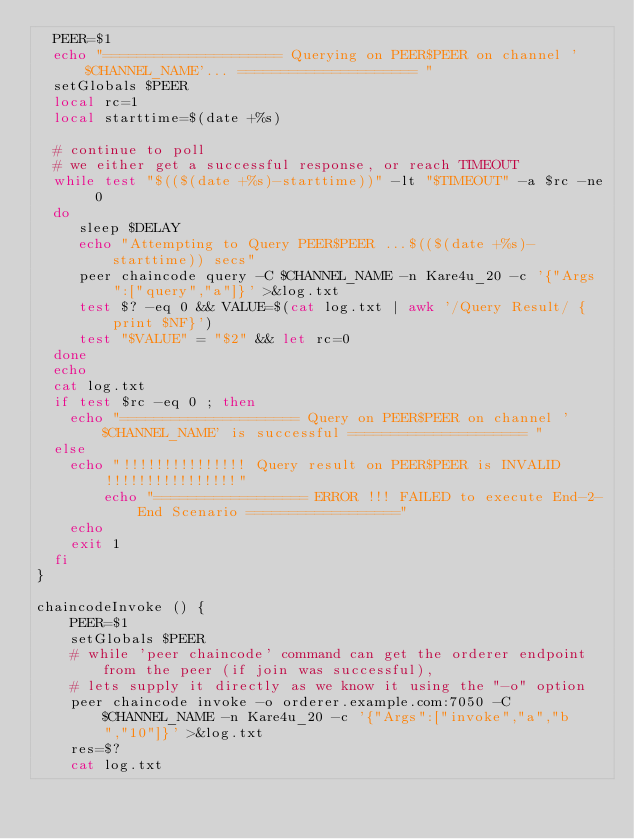<code> <loc_0><loc_0><loc_500><loc_500><_Bash_>  PEER=$1
  echo "===================== Querying on PEER$PEER on channel '$CHANNEL_NAME'... ===================== "
  setGlobals $PEER
  local rc=1
  local starttime=$(date +%s)

  # continue to poll
  # we either get a successful response, or reach TIMEOUT
  while test "$(($(date +%s)-starttime))" -lt "$TIMEOUT" -a $rc -ne 0
  do
     sleep $DELAY
     echo "Attempting to Query PEER$PEER ...$(($(date +%s)-starttime)) secs"
     peer chaincode query -C $CHANNEL_NAME -n Kare4u_20 -c '{"Args":["query","a"]}' >&log.txt
     test $? -eq 0 && VALUE=$(cat log.txt | awk '/Query Result/ {print $NF}')
     test "$VALUE" = "$2" && let rc=0
  done
  echo
  cat log.txt
  if test $rc -eq 0 ; then
	echo "===================== Query on PEER$PEER on channel '$CHANNEL_NAME' is successful ===================== "
  else
	echo "!!!!!!!!!!!!!!! Query result on PEER$PEER is INVALID !!!!!!!!!!!!!!!!"
        echo "================== ERROR !!! FAILED to execute End-2-End Scenario =================="
	echo
	exit 1
  fi
}

chaincodeInvoke () {
	PEER=$1
	setGlobals $PEER
	# while 'peer chaincode' command can get the orderer endpoint from the peer (if join was successful),
	# lets supply it directly as we know it using the "-o" option
	peer chaincode invoke -o orderer.example.com:7050 -C $CHANNEL_NAME -n Kare4u_20 -c '{"Args":["invoke","a","b","10"]}' >&log.txt
	res=$?
	cat log.txt</code> 